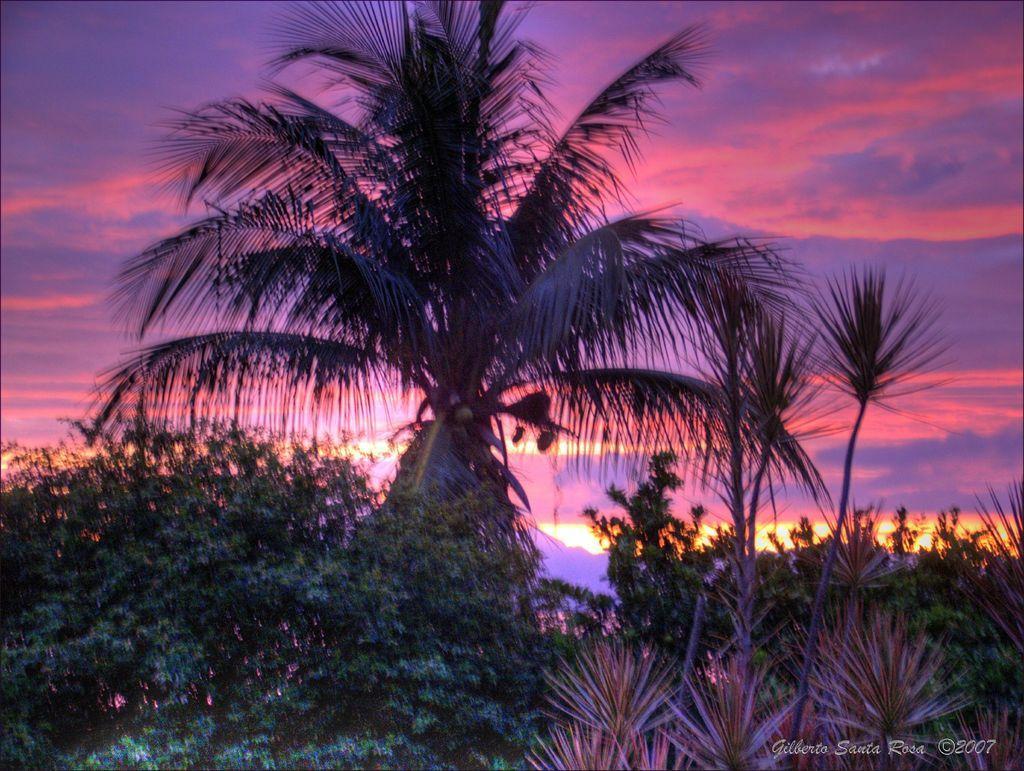Describe this image in one or two sentences. In the foreground of the picture I can see the trees. I can see a coconut tree at the top of the picture. There are clouds in the sky. 